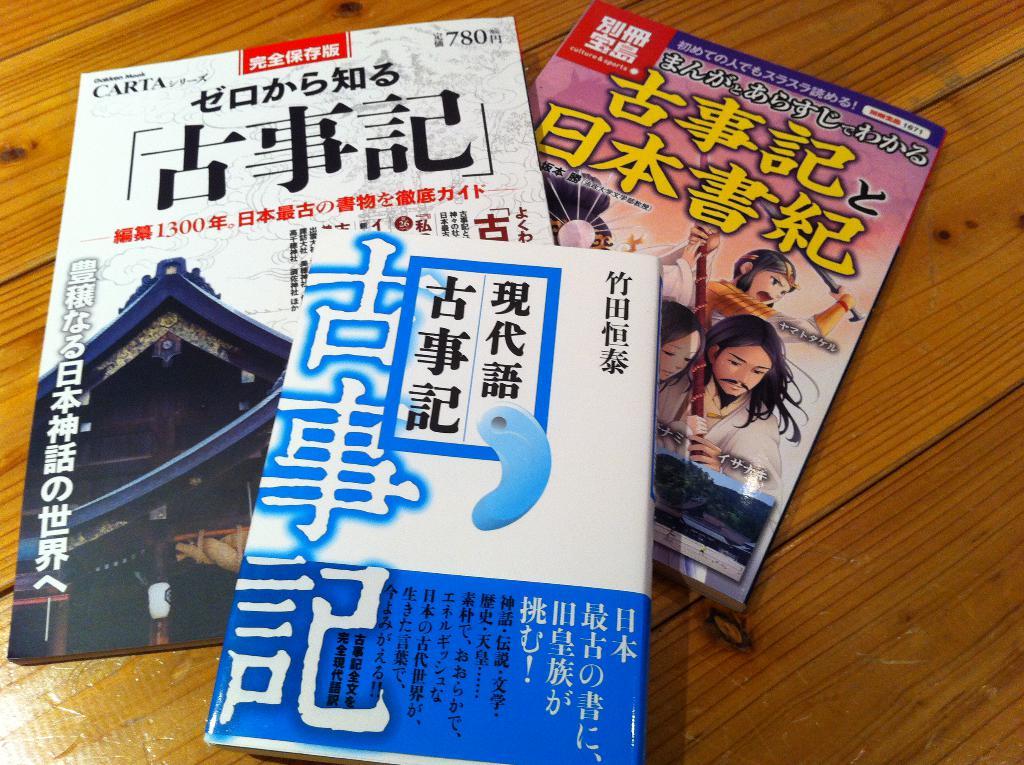What's the number at the top right of the book on the left?
Your answer should be compact. 780. 